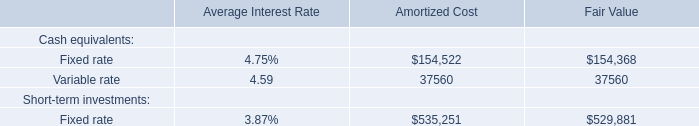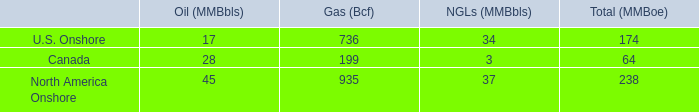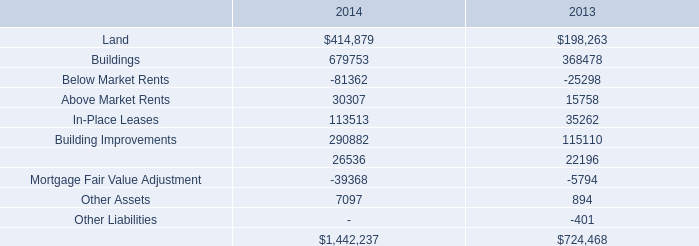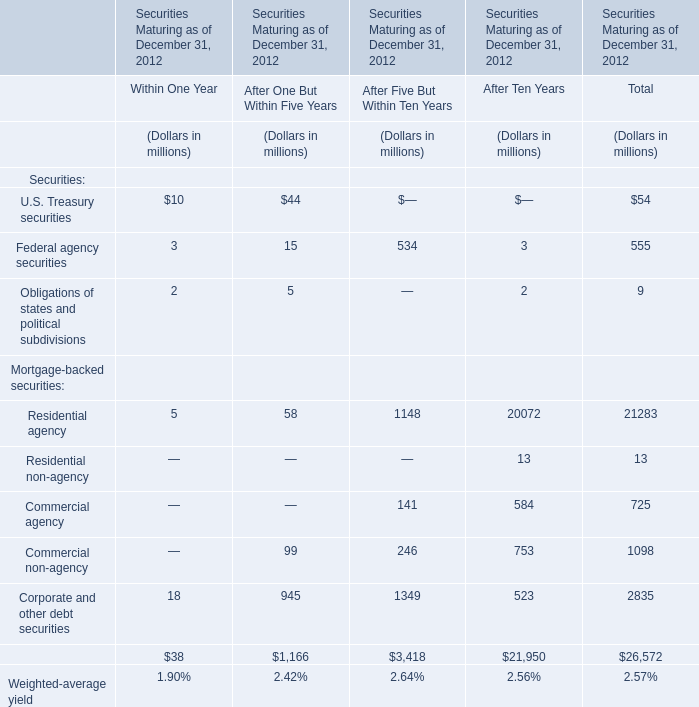What's the average of Below Market Rents of 2014, and Fixed rate of Amortized Cost ? 
Computations: ((81362.0 + 154522.0) / 2)
Answer: 117942.0. 